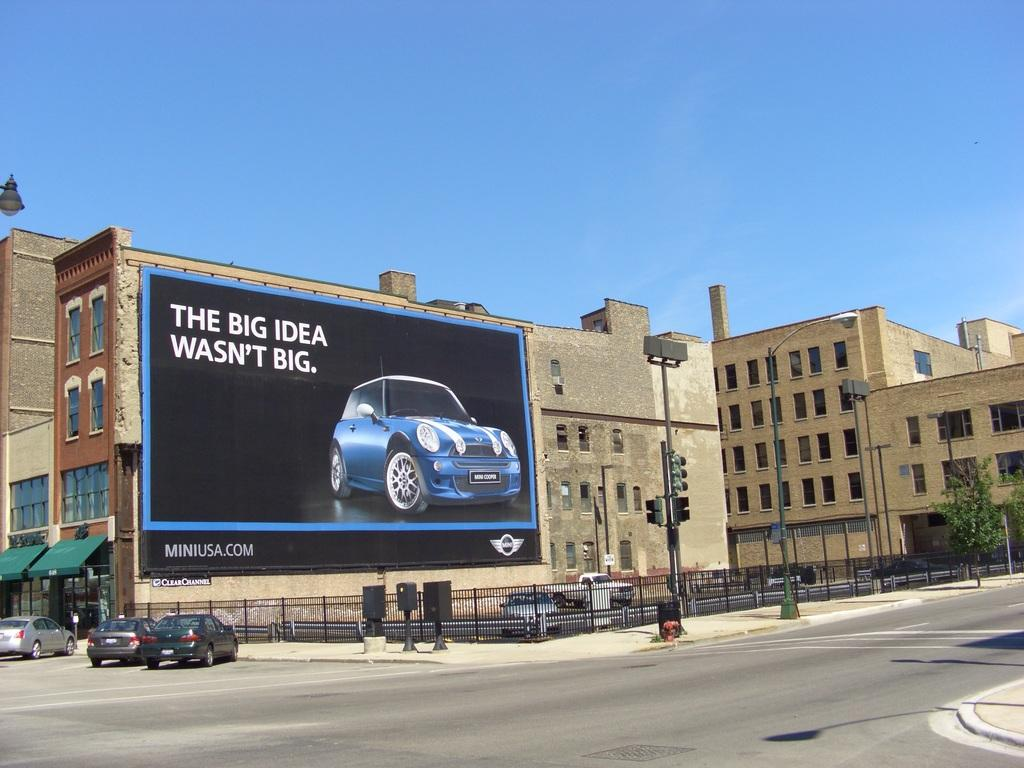<image>
Summarize the visual content of the image. a billboard in front of a building that says 'the big idea wasn't big' 